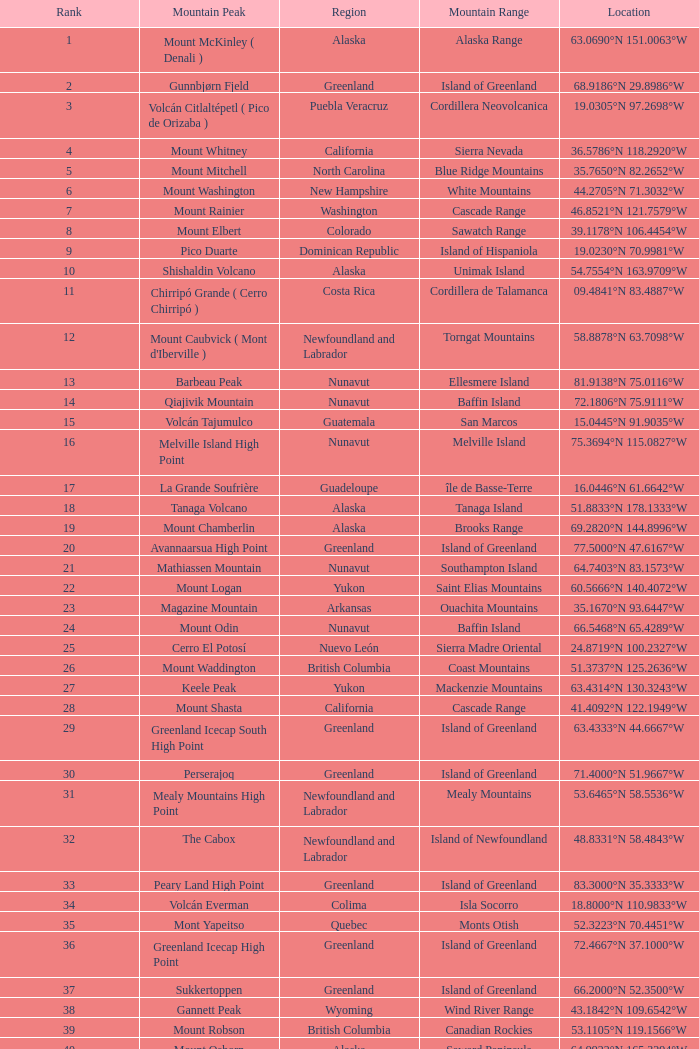In which region can the dillingham high point mountain peak be found? Alaska. 